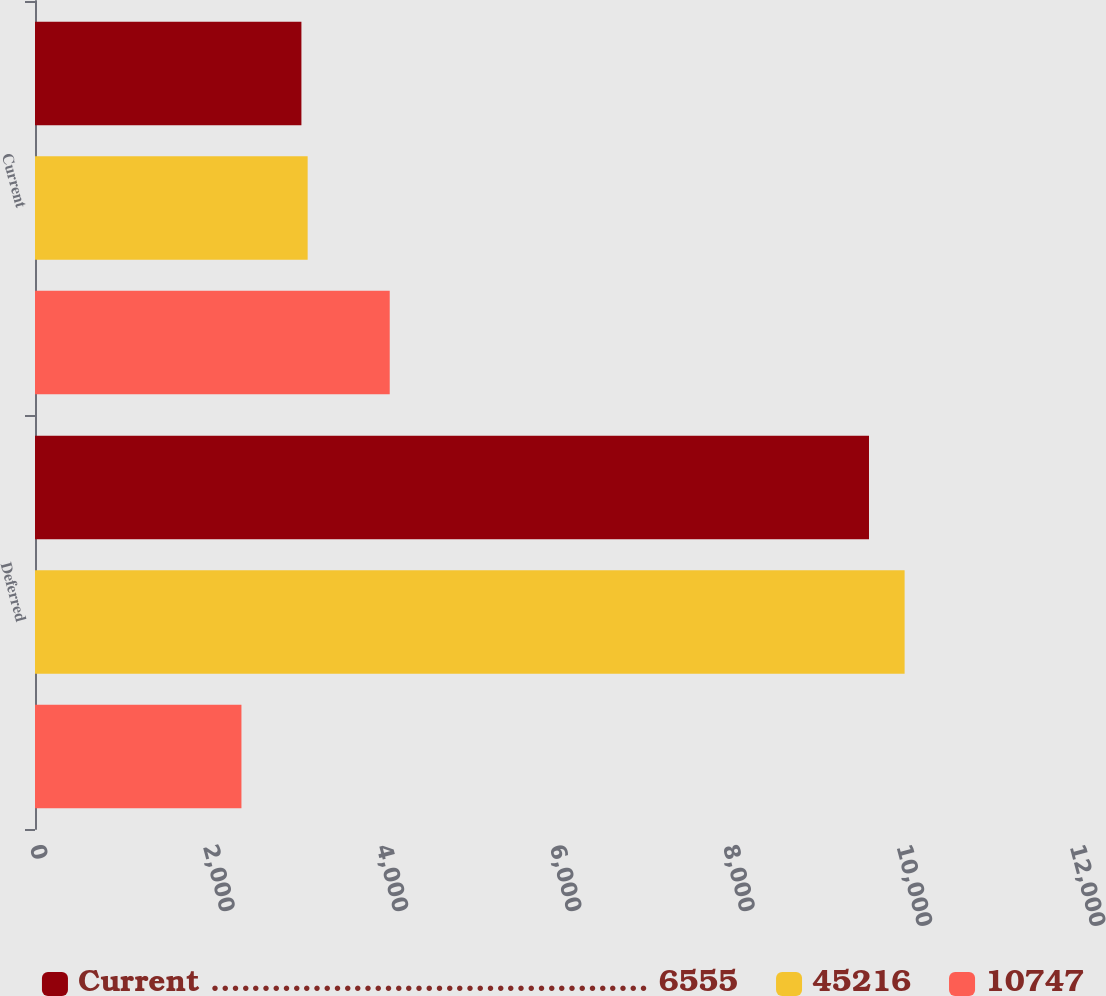<chart> <loc_0><loc_0><loc_500><loc_500><stacked_bar_chart><ecel><fcel>Deferred<fcel>Current<nl><fcel>Current ........................................... 6555<fcel>9623<fcel>3074<nl><fcel>45216<fcel>10034<fcel>3146<nl><fcel>10747<fcel>2382<fcel>4093<nl></chart> 